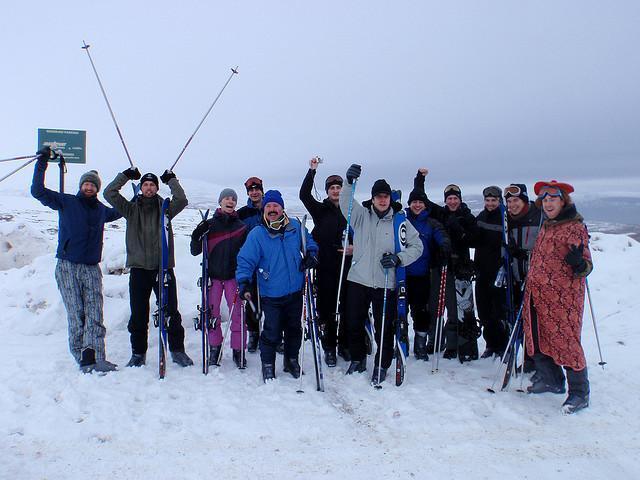How many people can be seen?
Give a very brief answer. 11. How many motorcycle do you see?
Give a very brief answer. 0. 